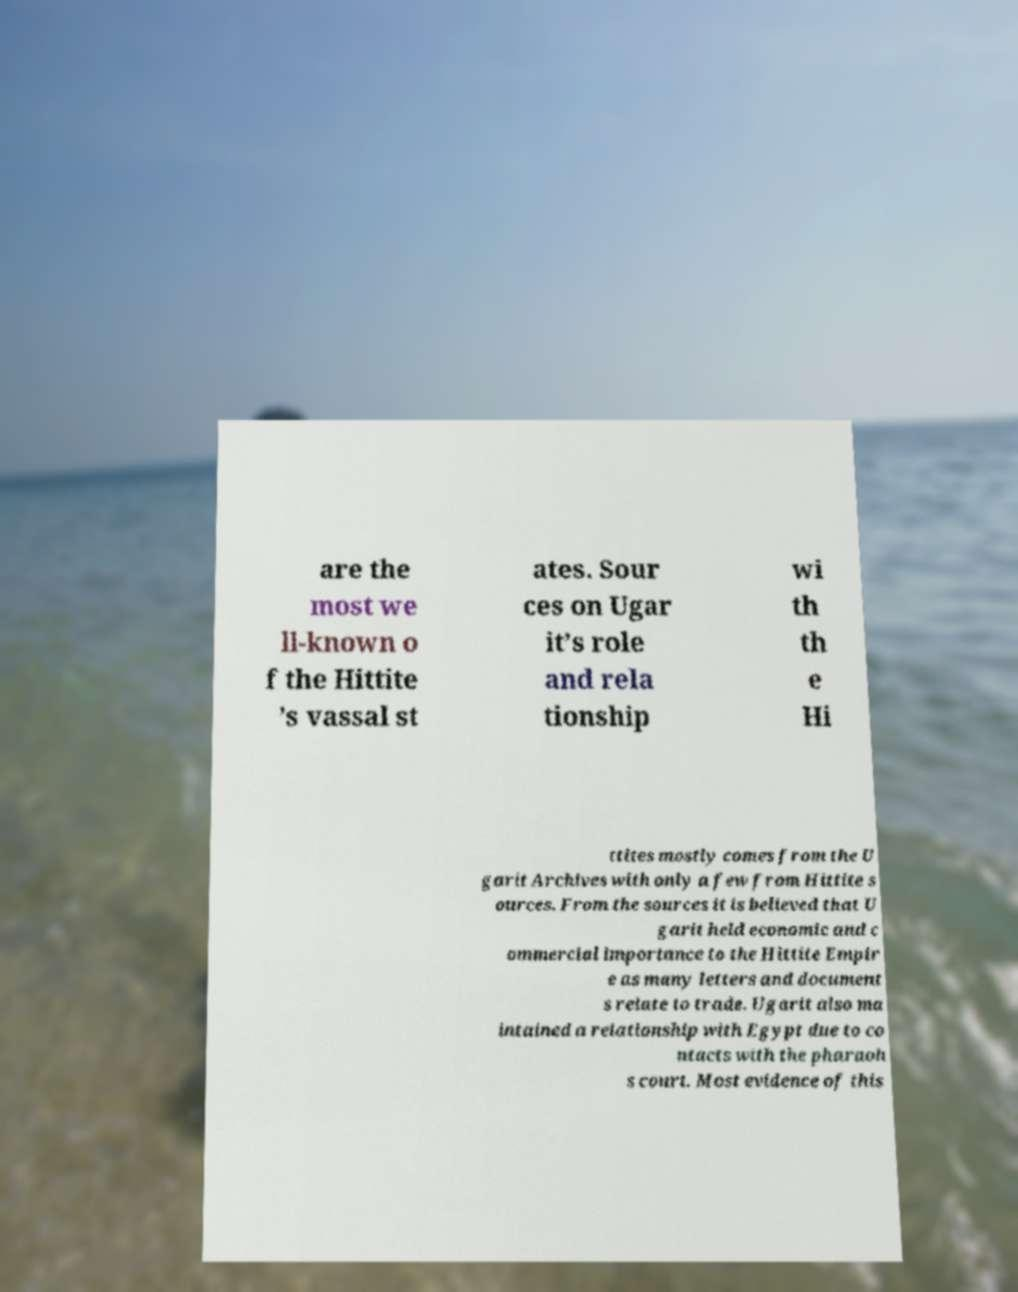I need the written content from this picture converted into text. Can you do that? are the most we ll-known o f the Hittite ’s vassal st ates. Sour ces on Ugar it’s role and rela tionship wi th th e Hi ttites mostly comes from the U garit Archives with only a few from Hittite s ources. From the sources it is believed that U garit held economic and c ommercial importance to the Hittite Empir e as many letters and document s relate to trade. Ugarit also ma intained a relationship with Egypt due to co ntacts with the pharaoh s court. Most evidence of this 